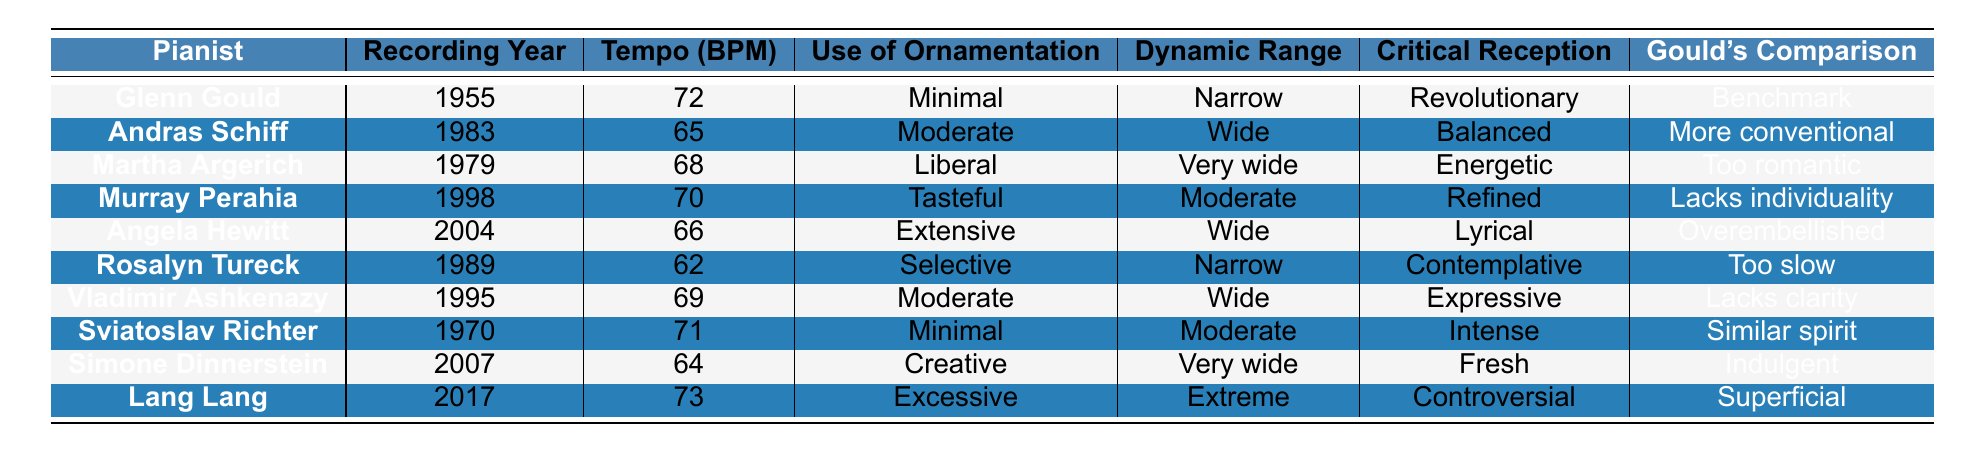What is the recording year of Glenn Gould's Bach interpretation? Glenn Gould's Bach interpretation is listed in the table with a recording year of 1955.
Answer: 1955 Which pianist had the widest dynamic range in their interpretation? The table shows that Martha Argerich had the widest dynamic range described as "Very wide."
Answer: Martha Argerich What is the tempo of the recording by Lang Lang? Lang Lang's recording is noted in the table with a tempo of 73 BPM.
Answer: 73 Which pianist is described as having a "Contemplative" critical reception? Looking at the table, Rosalyn Tureck's performance is labeled as "Contemplative" in the Critical Reception column.
Answer: Rosalyn Tureck What is the difference in tempo between Angela Hewitt’s and Sviatoslav Richter's recordings? Angela Hewitt's tempo is 66 BPM and Sviatoslav Richter's is 71 BPM. The difference is 71 - 66 = 5 BPM.
Answer: 5 BPM Is it true that Glenn Gould's interpretation is considered a benchmark compared to others? Yes, the table indicates that Gould's interpretation is labeled as a "Benchmark" in the Gould's Comparison column.
Answer: Yes Which pianist's interpretation is categorized as "Indulgent" and what year was that recording made? The table shows that Simone Dinnerstein's interpretation is labeled as "Indulgent" and was recorded in 2007.
Answer: Simone Dinnerstein, 2007 Which two pianists recorded their interpretations in the 1980s? Referring to the table, the two pianists who recorded in the 1980s are Andras Schiff (1983) and Rosalyn Tureck (1989).
Answer: Andras Schiff and Rosalyn Tureck What can be inferred about the overall use of ornamentation by the pianists compared to Gould? By comparing the Use of Ornamentation column, we see that Gould's "Minimal" style contrasts with the "Liberal" and "Extensive" styles of some pianists, indicating a tendency toward more embellishment in later interpretations.
Answer: Contrast in ornamentation styles Who is considered the most energetic pianist based on critical reception? The table indicates that Martha Argerich is described as "Energetic" in her critical reception.
Answer: Martha Argerich 